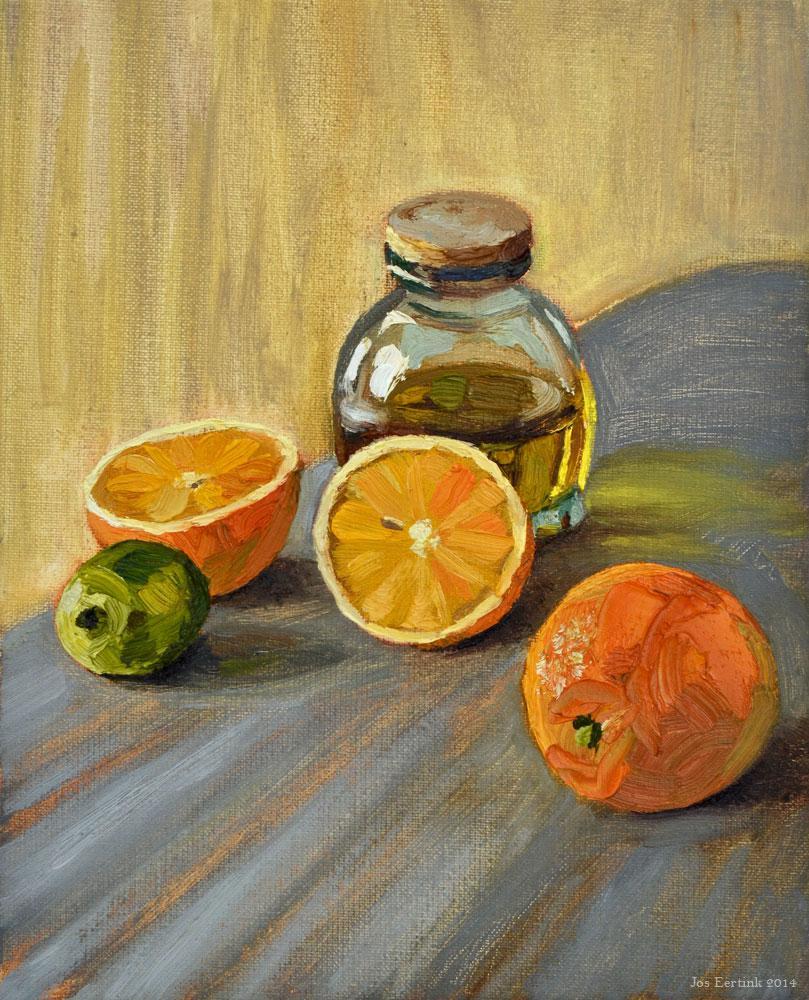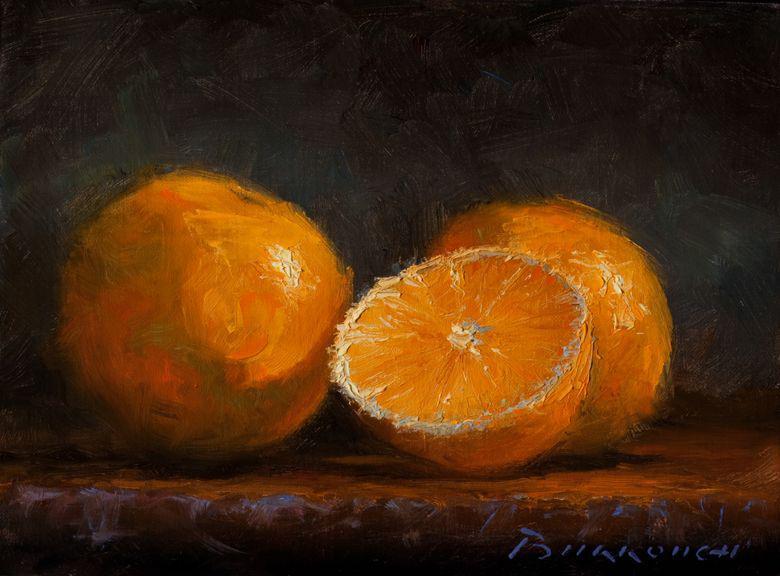The first image is the image on the left, the second image is the image on the right. Analyze the images presented: Is the assertion "In at least on of the images, bunches of grapes are sitting on a table near some oranges." valid? Answer yes or no. No. The first image is the image on the left, the second image is the image on the right. For the images shown, is this caption "One image shows a peeled orange with its peel loosely around it, in front of a bunch of grapes." true? Answer yes or no. No. 